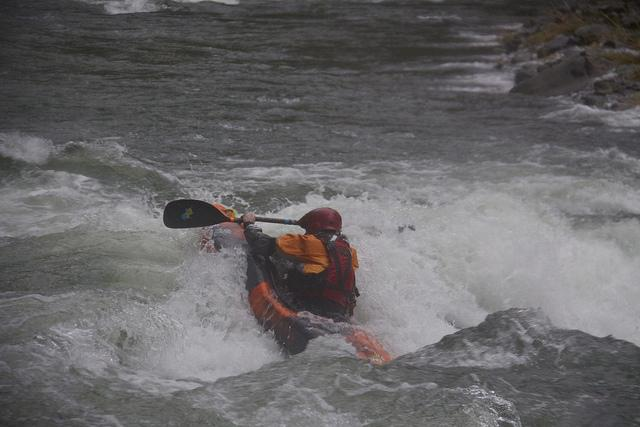What life threatening danger does this kayaker face if the waves get to high? drowning 